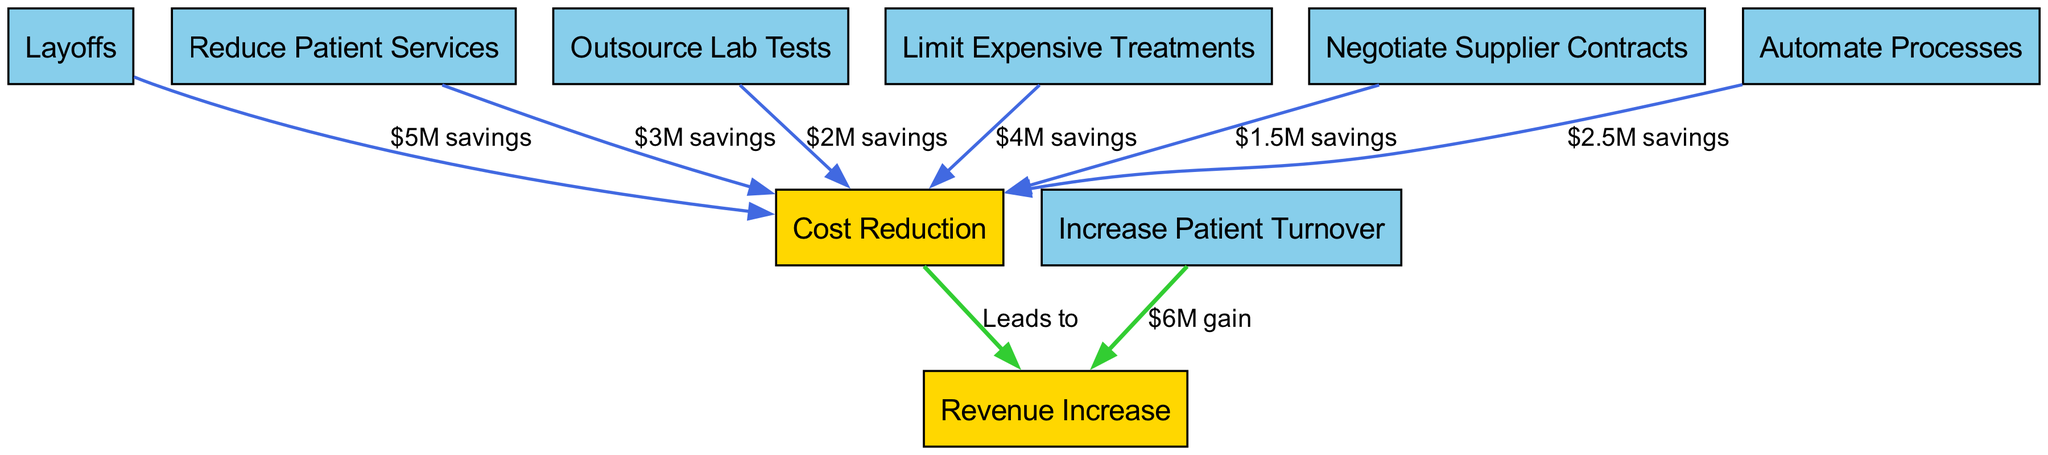What is the total number of nodes in the diagram? The diagram contains a list of nodes which includes: Revenue Increase, Cost Reduction, Layoffs, Reduce Patient Services, Outsource Lab Tests, Limit Expensive Treatments, Negotiate Supplier Contracts, Increase Patient Turnover, and Automate Processes. Counting these, we find there are 9 nodes total.
Answer: 9 How much savings is estimated from Layoffs? The diagram shows that Layoffs lead to a Cost Reduction which results in $5M savings. This is a direct label on the edge connecting Layoffs to Cost Reduction.
Answer: $5M savings Which action has the highest projected savings? By looking at the edges leading into the Cost Reduction node, we see each connection's savings value. The highest amounts listed are Layoffs at $5M and Limit Expensive Treatments at $4M. However, Layoffs has the confirmed highest projected savings.
Answer: Layoffs What does 'Increase Patient Turnover' lead to? The diagram indicates that 'Increase Patient Turnover' leads to 'Revenue Increase', as shown by the directed edge from Increase Patient Turnover to Revenue Increase. The edge also specifies a $6M gain.
Answer: Revenue Increase What is the total projected savings from all cost reduction methods? By summing the savings from all identified cost reduction actions: Layoffs ($5M), Reduce Patient Services ($3M), Outsource Lab Tests ($2M), Limit Expensive Treatments ($4M), Negotiate Supplier Contracts ($1.5M), and Automate Processes ($2.5M), we get a total savings of $18M.
Answer: $18M What would happen if we negotiate supplier contracts? Negotiating Supplier Contracts leads to Cost Reduction with projected savings of $1.5M. It shows a direct relationship where this action contributes towards reducing costs.
Answer: Cost Reduction How many edges are directed towards 'Cost Reduction'? The directed edges towards the 'Cost Reduction' node come from several actions: Layoffs, Reduce Patient Services, Outsource Lab Tests, Limit Expensive Treatments, Negotiate Supplier Contracts, and Automate Processes. Counting these connections gives a total of 6 edges.
Answer: 6 edges Which two measures together contribute a total of $7M in savings? The measures 'Layoffs' ($5M) and 'Negotiate Supplier Contracts' ($1.5M) together contribute $7M in savings. By summing these two specific savings, we confirm this combined figure.
Answer: Layoffs and Negotiate Supplier Contracts What is the relationship between 'Automate Processes' and 'Cost Reduction'? The diagram shows that 'Automate Processes' leads to 'Cost Reduction', with an associated savings of $2.5M. This directional edge confirms the positive impact of automating processes on reducing costs.
Answer: Cost Reduction 